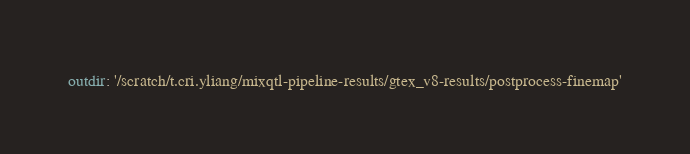Convert code to text. <code><loc_0><loc_0><loc_500><loc_500><_YAML_>outdir: '/scratch/t.cri.yliang/mixqtl-pipeline-results/gtex_v8-results/postprocess-finemap'</code> 